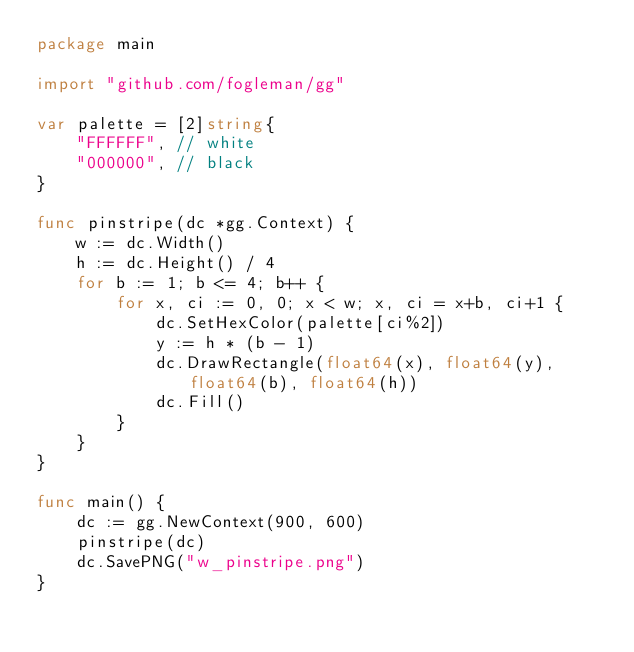Convert code to text. <code><loc_0><loc_0><loc_500><loc_500><_Go_>package main

import "github.com/fogleman/gg"

var palette = [2]string{
    "FFFFFF", // white
    "000000", // black
}

func pinstripe(dc *gg.Context) {
    w := dc.Width()
    h := dc.Height() / 4
    for b := 1; b <= 4; b++ {
        for x, ci := 0, 0; x < w; x, ci = x+b, ci+1 {
            dc.SetHexColor(palette[ci%2])
            y := h * (b - 1)
            dc.DrawRectangle(float64(x), float64(y), float64(b), float64(h))
            dc.Fill()
        }
    }
}

func main() {
    dc := gg.NewContext(900, 600)
    pinstripe(dc)
    dc.SavePNG("w_pinstripe.png")
}
</code> 